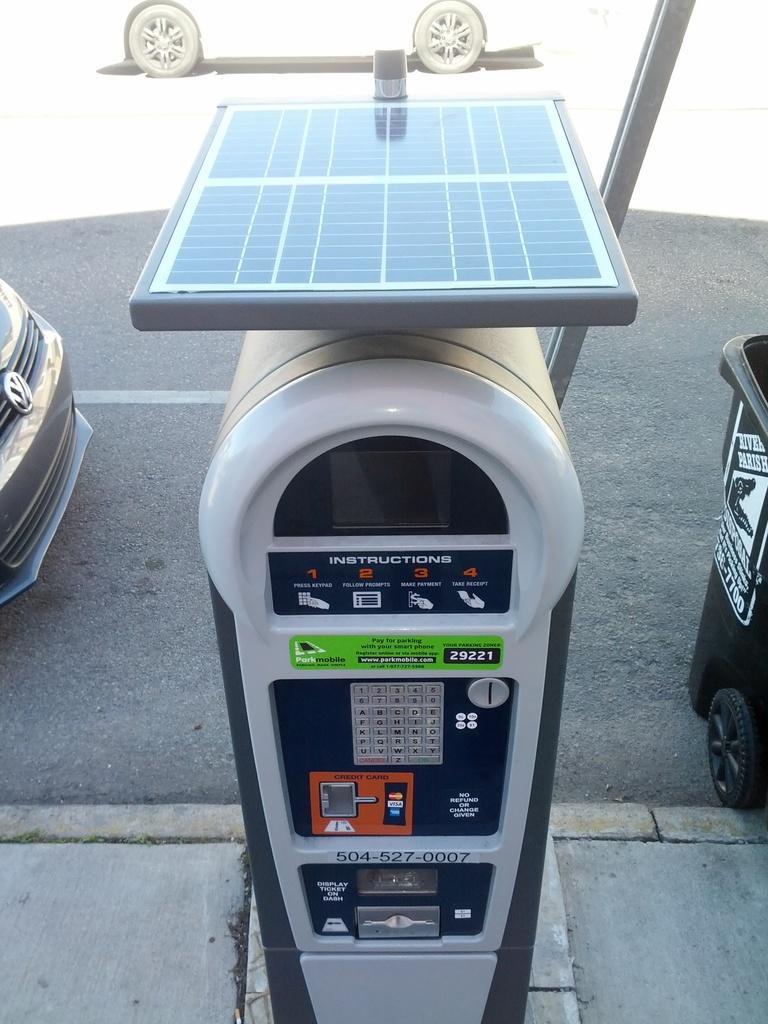Could you give a brief overview of what you see in this image? In this image we can see a parking meter and vehicles on the road. Right side, we can see it looks like a dustbin on the road. 